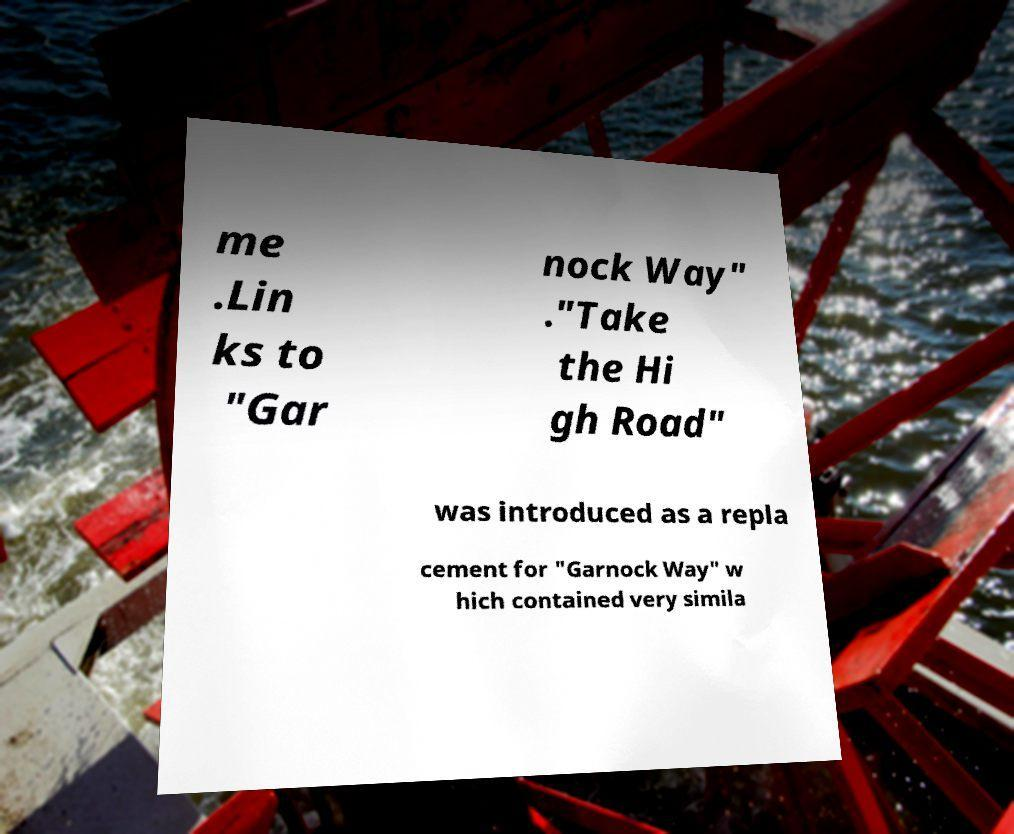What messages or text are displayed in this image? I need them in a readable, typed format. me .Lin ks to "Gar nock Way" ."Take the Hi gh Road" was introduced as a repla cement for "Garnock Way" w hich contained very simila 